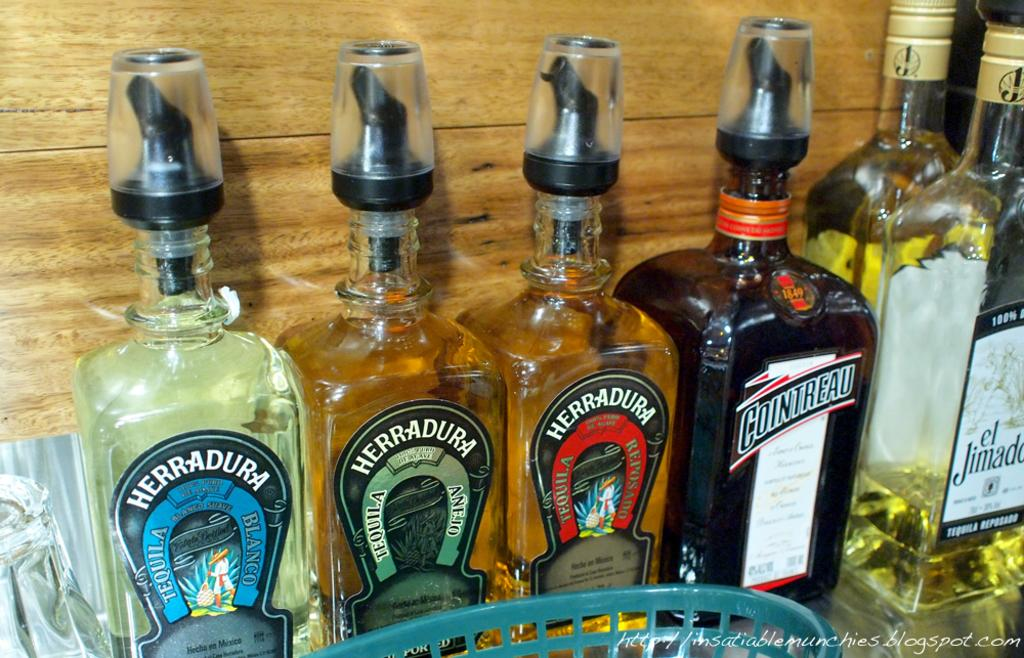<image>
Render a clear and concise summary of the photo. A couple of Herradura tequila bottles are among a collection of liquor bottles. 